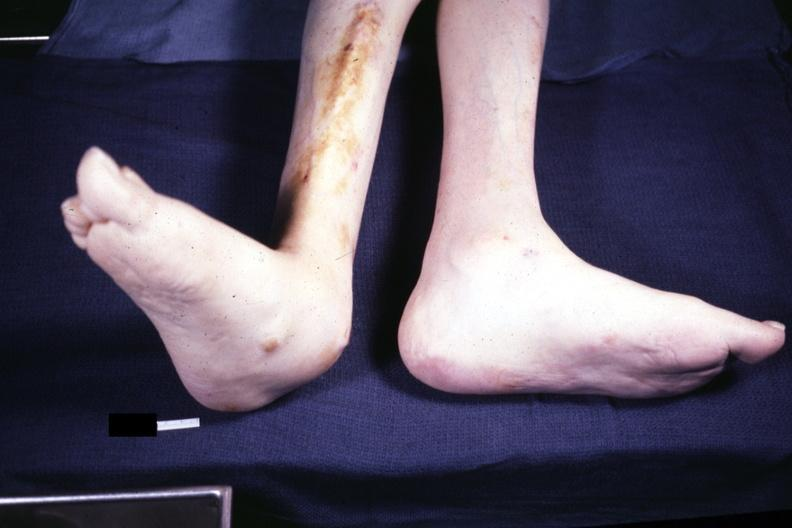s rheumatoid arthritis present?
Answer the question using a single word or phrase. Yes 